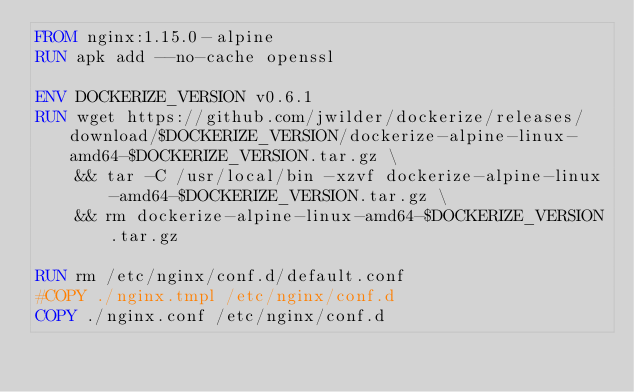<code> <loc_0><loc_0><loc_500><loc_500><_Dockerfile_>FROM nginx:1.15.0-alpine
RUN apk add --no-cache openssl

ENV DOCKERIZE_VERSION v0.6.1
RUN wget https://github.com/jwilder/dockerize/releases/download/$DOCKERIZE_VERSION/dockerize-alpine-linux-amd64-$DOCKERIZE_VERSION.tar.gz \
    && tar -C /usr/local/bin -xzvf dockerize-alpine-linux-amd64-$DOCKERIZE_VERSION.tar.gz \
    && rm dockerize-alpine-linux-amd64-$DOCKERIZE_VERSION.tar.gz

RUN rm /etc/nginx/conf.d/default.conf
#COPY ./nginx.tmpl /etc/nginx/conf.d
COPY ./nginx.conf /etc/nginx/conf.d</code> 